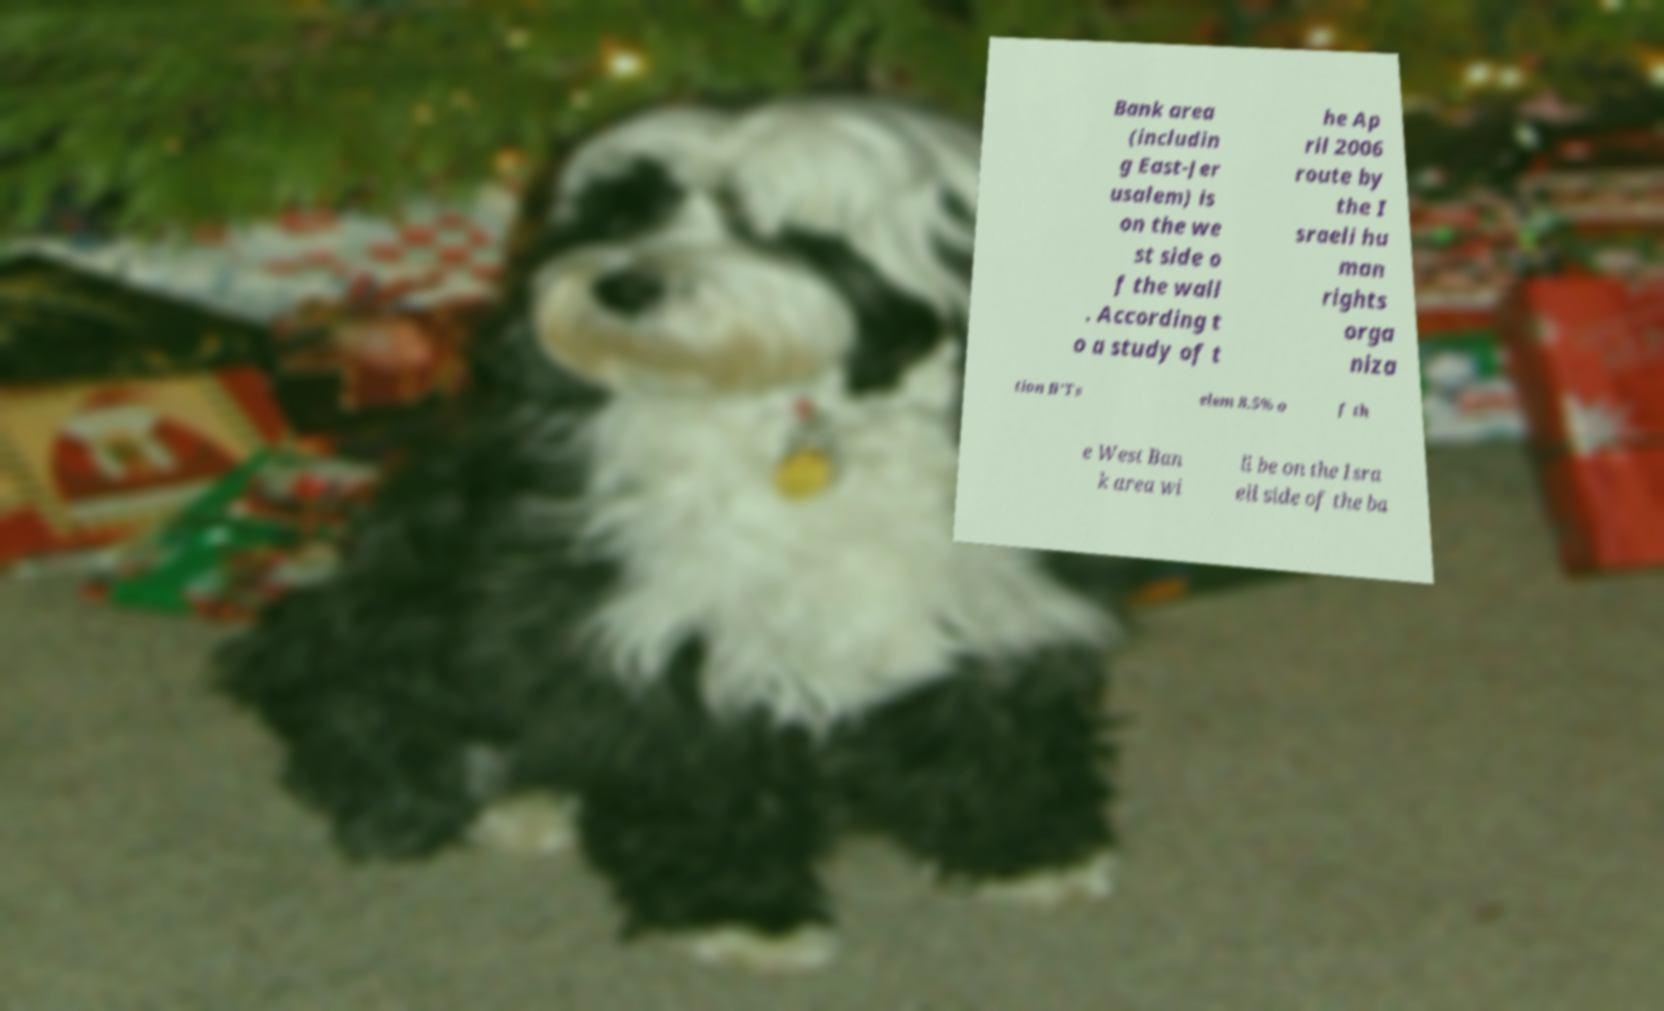Could you extract and type out the text from this image? Bank area (includin g East-Jer usalem) is on the we st side o f the wall . According t o a study of t he Ap ril 2006 route by the I sraeli hu man rights orga niza tion B'Ts elem 8.5% o f th e West Ban k area wi ll be on the Isra eli side of the ba 